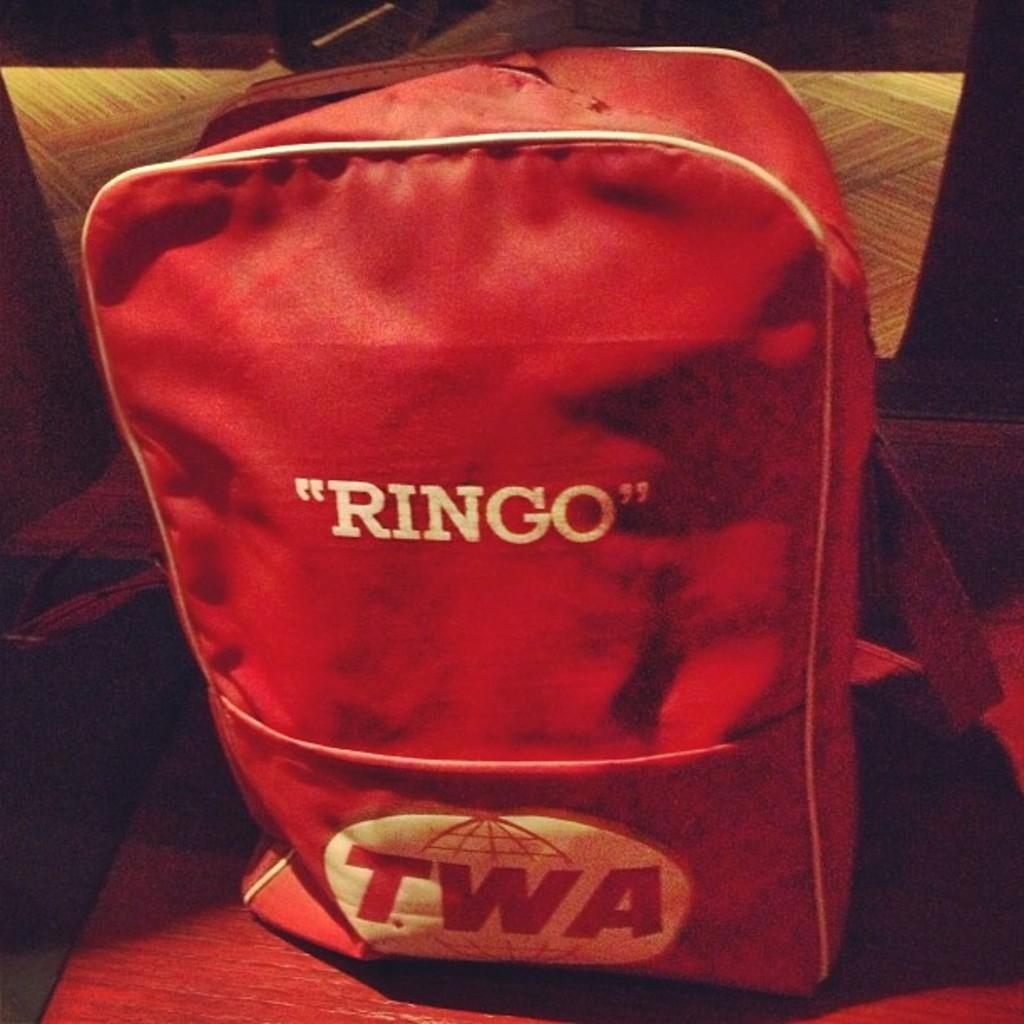What color is the bag in the image? The bag in the image is red. What is written on the bag? The word "Ringo" is written on the bag. What is the condition of the spy in the image? There is no spy present in the image; it only features a red color bag with the word "Ringo" written on it. 